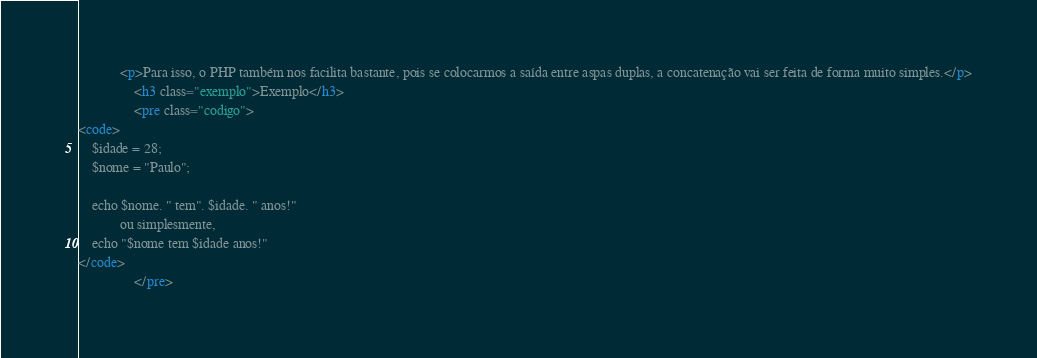<code> <loc_0><loc_0><loc_500><loc_500><_HTML_>            <p>Para isso, o PHP também nos facilita bastante, pois se colocarmos a saída entre aspas duplas, a concatenação vai ser feita de forma muito simples.</p>
                <h3 class="exemplo">Exemplo</h3>
                <pre class="codigo">
<code>
    $idade = 28;
    $nome = "Paulo";

    echo $nome. " tem". $idade. " anos!"
            ou simplesmente,
    echo "$nome tem $idade anos!"
</code>
                </pre></code> 